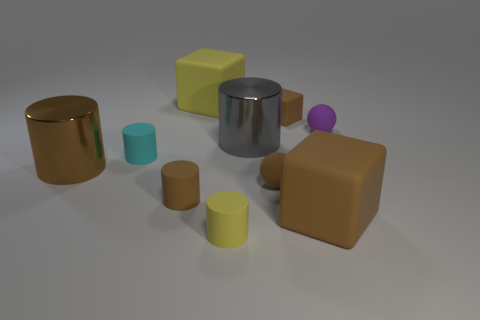Subtract all yellow cylinders. How many cylinders are left? 4 Subtract all brown rubber cylinders. How many cylinders are left? 4 Subtract 0 gray blocks. How many objects are left? 10 Subtract all balls. How many objects are left? 8 Subtract 4 cylinders. How many cylinders are left? 1 Subtract all blue balls. Subtract all red cylinders. How many balls are left? 2 Subtract all blue cylinders. How many blue blocks are left? 0 Subtract all big blue metallic cubes. Subtract all big brown cylinders. How many objects are left? 9 Add 9 large brown matte blocks. How many large brown matte blocks are left? 10 Add 7 yellow cylinders. How many yellow cylinders exist? 8 